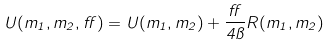<formula> <loc_0><loc_0><loc_500><loc_500>U ( m _ { 1 } , m _ { 2 } , \alpha ) = U ( m _ { 1 } , m _ { 2 } ) + \frac { \alpha } { 4 \pi } R ( m _ { 1 } , m _ { 2 } )</formula> 